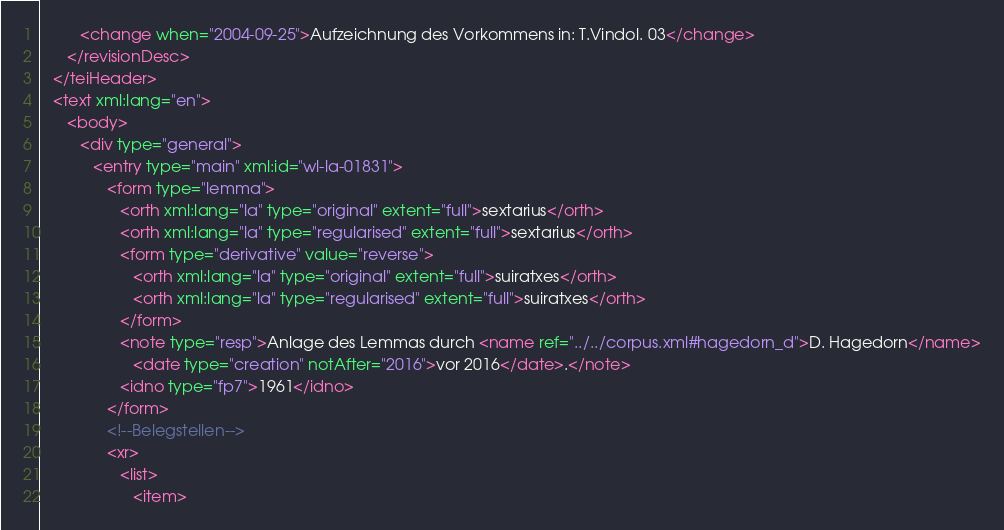<code> <loc_0><loc_0><loc_500><loc_500><_XML_>         <change when="2004-09-25">Aufzeichnung des Vorkommens in: T.Vindol. 03</change>
      </revisionDesc>
   </teiHeader>
   <text xml:lang="en">
      <body>
         <div type="general">
            <entry type="main" xml:id="wl-la-01831">
               <form type="lemma">
                  <orth xml:lang="la" type="original" extent="full">sextarius</orth>
                  <orth xml:lang="la" type="regularised" extent="full">sextarius</orth>
                  <form type="derivative" value="reverse">
                     <orth xml:lang="la" type="original" extent="full">suiratxes</orth>
                     <orth xml:lang="la" type="regularised" extent="full">suiratxes</orth>
                  </form>
                  <note type="resp">Anlage des Lemmas durch <name ref="../../corpus.xml#hagedorn_d">D. Hagedorn</name>
                     <date type="creation" notAfter="2016">vor 2016</date>.</note>
                  <idno type="fp7">1961</idno>
               </form>
               <!--Belegstellen-->
               <xr>
                  <list>
                     <item></code> 